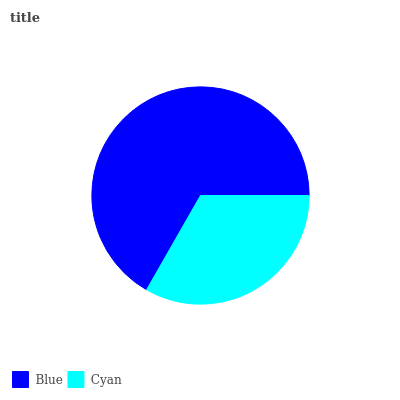Is Cyan the minimum?
Answer yes or no. Yes. Is Blue the maximum?
Answer yes or no. Yes. Is Cyan the maximum?
Answer yes or no. No. Is Blue greater than Cyan?
Answer yes or no. Yes. Is Cyan less than Blue?
Answer yes or no. Yes. Is Cyan greater than Blue?
Answer yes or no. No. Is Blue less than Cyan?
Answer yes or no. No. Is Blue the high median?
Answer yes or no. Yes. Is Cyan the low median?
Answer yes or no. Yes. Is Cyan the high median?
Answer yes or no. No. Is Blue the low median?
Answer yes or no. No. 